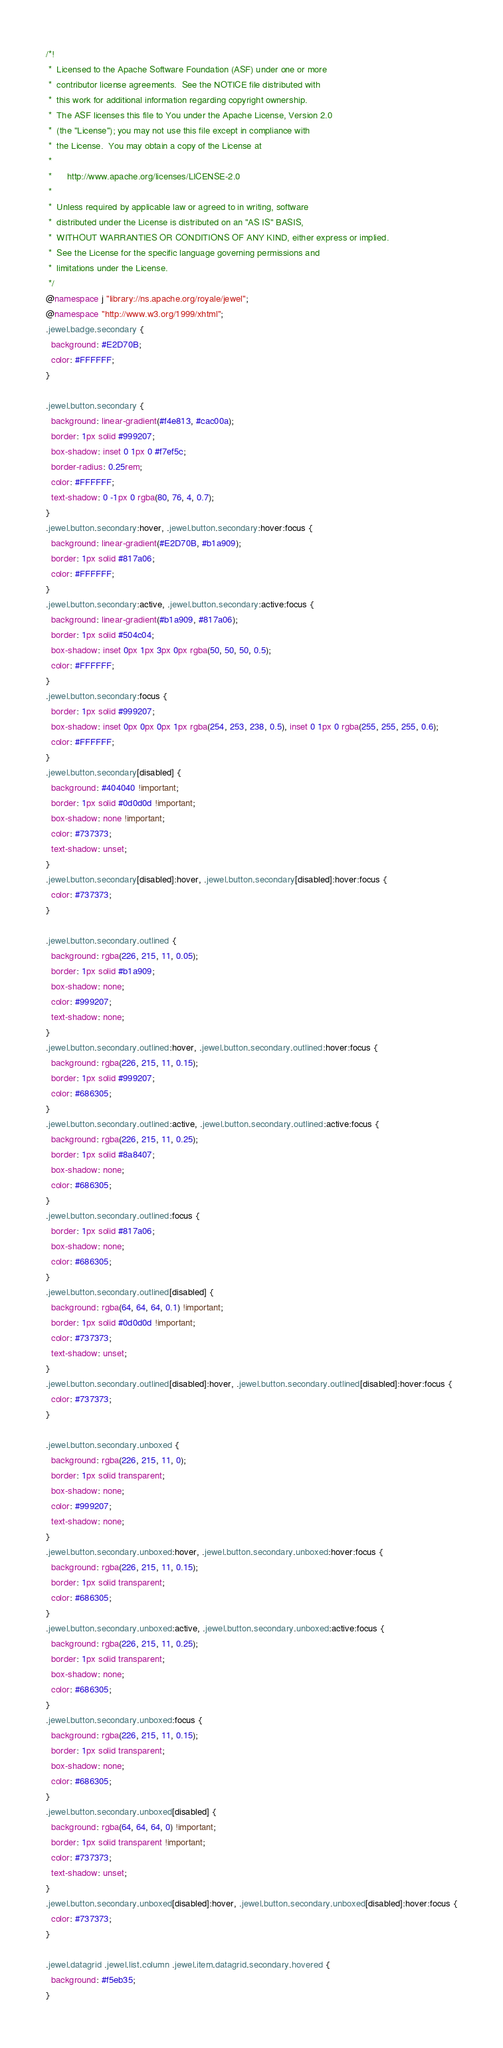Convert code to text. <code><loc_0><loc_0><loc_500><loc_500><_CSS_>/*!
 *  Licensed to the Apache Software Foundation (ASF) under one or more
 *  contributor license agreements.  See the NOTICE file distributed with
 *  this work for additional information regarding copyright ownership.
 *  The ASF licenses this file to You under the Apache License, Version 2.0
 *  (the "License"); you may not use this file except in compliance with
 *  the License.  You may obtain a copy of the License at
 *
 *      http://www.apache.org/licenses/LICENSE-2.0
 *
 *  Unless required by applicable law or agreed to in writing, software
 *  distributed under the License is distributed on an "AS IS" BASIS,
 *  WITHOUT WARRANTIES OR CONDITIONS OF ANY KIND, either express or implied.
 *  See the License for the specific language governing permissions and
 *  limitations under the License.
 */
@namespace j "library://ns.apache.org/royale/jewel";
@namespace "http://www.w3.org/1999/xhtml";
.jewel.badge.secondary {
  background: #E2D70B;
  color: #FFFFFF;
}

.jewel.button.secondary {
  background: linear-gradient(#f4e813, #cac00a);
  border: 1px solid #999207;
  box-shadow: inset 0 1px 0 #f7ef5c;
  border-radius: 0.25rem;
  color: #FFFFFF;
  text-shadow: 0 -1px 0 rgba(80, 76, 4, 0.7);
}
.jewel.button.secondary:hover, .jewel.button.secondary:hover:focus {
  background: linear-gradient(#E2D70B, #b1a909);
  border: 1px solid #817a06;
  color: #FFFFFF;
}
.jewel.button.secondary:active, .jewel.button.secondary:active:focus {
  background: linear-gradient(#b1a909, #817a06);
  border: 1px solid #504c04;
  box-shadow: inset 0px 1px 3px 0px rgba(50, 50, 50, 0.5);
  color: #FFFFFF;
}
.jewel.button.secondary:focus {
  border: 1px solid #999207;
  box-shadow: inset 0px 0px 0px 1px rgba(254, 253, 238, 0.5), inset 0 1px 0 rgba(255, 255, 255, 0.6);
  color: #FFFFFF;
}
.jewel.button.secondary[disabled] {
  background: #404040 !important;
  border: 1px solid #0d0d0d !important;
  box-shadow: none !important;
  color: #737373;
  text-shadow: unset;
}
.jewel.button.secondary[disabled]:hover, .jewel.button.secondary[disabled]:hover:focus {
  color: #737373;
}

.jewel.button.secondary.outlined {
  background: rgba(226, 215, 11, 0.05);
  border: 1px solid #b1a909;
  box-shadow: none;
  color: #999207;
  text-shadow: none;
}
.jewel.button.secondary.outlined:hover, .jewel.button.secondary.outlined:hover:focus {
  background: rgba(226, 215, 11, 0.15);
  border: 1px solid #999207;
  color: #686305;
}
.jewel.button.secondary.outlined:active, .jewel.button.secondary.outlined:active:focus {
  background: rgba(226, 215, 11, 0.25);
  border: 1px solid #8a8407;
  box-shadow: none;
  color: #686305;
}
.jewel.button.secondary.outlined:focus {
  border: 1px solid #817a06;
  box-shadow: none;
  color: #686305;
}
.jewel.button.secondary.outlined[disabled] {
  background: rgba(64, 64, 64, 0.1) !important;
  border: 1px solid #0d0d0d !important;
  color: #737373;
  text-shadow: unset;
}
.jewel.button.secondary.outlined[disabled]:hover, .jewel.button.secondary.outlined[disabled]:hover:focus {
  color: #737373;
}

.jewel.button.secondary.unboxed {
  background: rgba(226, 215, 11, 0);
  border: 1px solid transparent;
  box-shadow: none;
  color: #999207;
  text-shadow: none;
}
.jewel.button.secondary.unboxed:hover, .jewel.button.secondary.unboxed:hover:focus {
  background: rgba(226, 215, 11, 0.15);
  border: 1px solid transparent;
  color: #686305;
}
.jewel.button.secondary.unboxed:active, .jewel.button.secondary.unboxed:active:focus {
  background: rgba(226, 215, 11, 0.25);
  border: 1px solid transparent;
  box-shadow: none;
  color: #686305;
}
.jewel.button.secondary.unboxed:focus {
  background: rgba(226, 215, 11, 0.15);
  border: 1px solid transparent;
  box-shadow: none;
  color: #686305;
}
.jewel.button.secondary.unboxed[disabled] {
  background: rgba(64, 64, 64, 0) !important;
  border: 1px solid transparent !important;
  color: #737373;
  text-shadow: unset;
}
.jewel.button.secondary.unboxed[disabled]:hover, .jewel.button.secondary.unboxed[disabled]:hover:focus {
  color: #737373;
}

.jewel.datagrid .jewel.list.column .jewel.item.datagrid.secondary.hovered {
  background: #f5eb35;
}</code> 